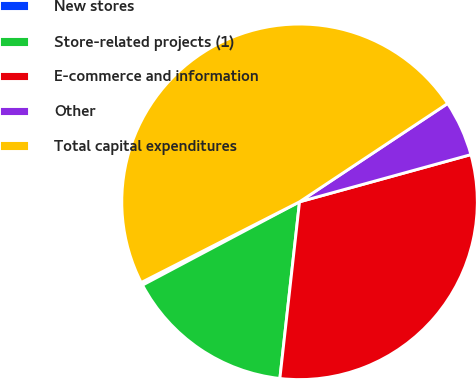Convert chart to OTSL. <chart><loc_0><loc_0><loc_500><loc_500><pie_chart><fcel>New stores<fcel>Store-related projects (1)<fcel>E-commerce and information<fcel>Other<fcel>Total capital expenditures<nl><fcel>0.26%<fcel>15.47%<fcel>31.04%<fcel>5.05%<fcel>48.17%<nl></chart> 